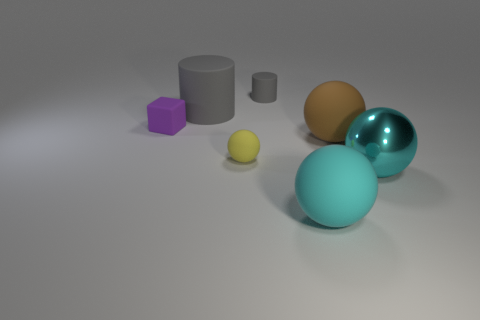Subtract all purple balls. Subtract all gray cylinders. How many balls are left? 4 Add 1 small gray balls. How many objects exist? 8 Subtract all spheres. How many objects are left? 3 Subtract 0 red cylinders. How many objects are left? 7 Subtract all large brown things. Subtract all tiny brown matte spheres. How many objects are left? 6 Add 1 cyan rubber balls. How many cyan rubber balls are left? 2 Add 2 yellow matte things. How many yellow matte things exist? 3 